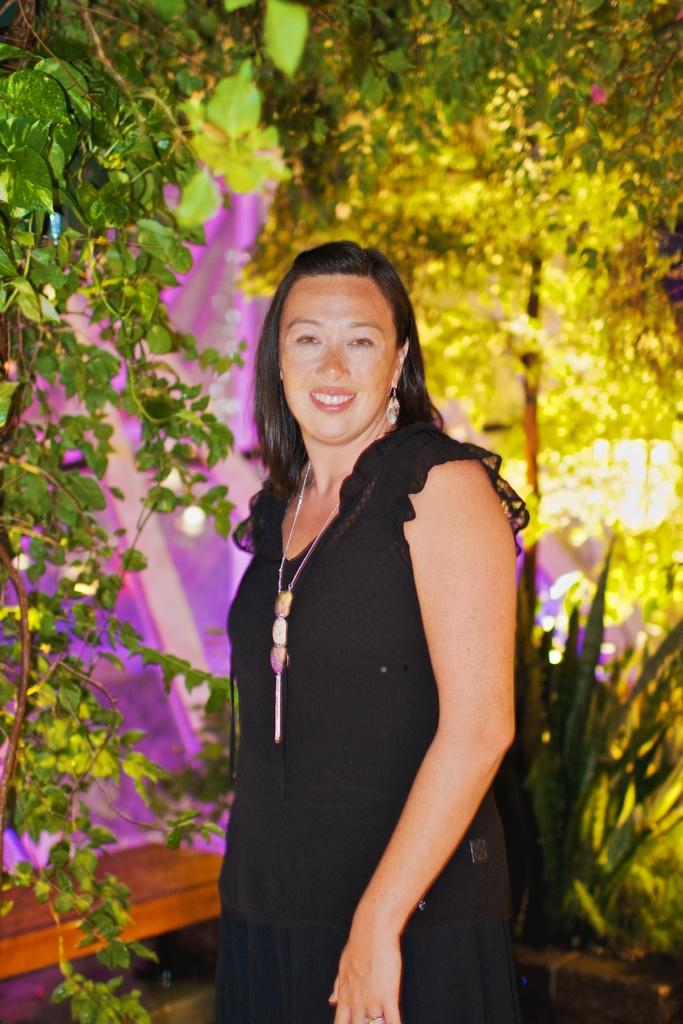Who is the main subject in the image? There is a lady in the image. What is the lady doing in the image? The lady is posing for a picture. What can be seen in the background behind the lady? There are trees and plants visible in the background. What is illuminating the scene in the image? There are lights visible in the image. What type of structure can be seen in the image? There is no structure present in the image; it features a lady posing for a picture with trees and plants in the background. How many branches are visible on the lady's arm in the image? The lady's arm is not depicted as having branches; it is a human arm. 